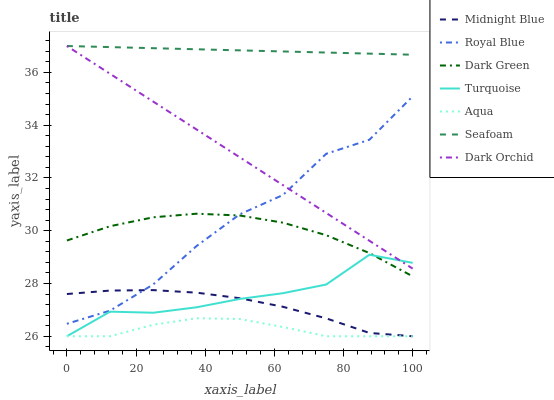Does Aqua have the minimum area under the curve?
Answer yes or no. Yes. Does Seafoam have the maximum area under the curve?
Answer yes or no. Yes. Does Midnight Blue have the minimum area under the curve?
Answer yes or no. No. Does Midnight Blue have the maximum area under the curve?
Answer yes or no. No. Is Seafoam the smoothest?
Answer yes or no. Yes. Is Royal Blue the roughest?
Answer yes or no. Yes. Is Midnight Blue the smoothest?
Answer yes or no. No. Is Midnight Blue the roughest?
Answer yes or no. No. Does Turquoise have the lowest value?
Answer yes or no. Yes. Does Seafoam have the lowest value?
Answer yes or no. No. Does Dark Orchid have the highest value?
Answer yes or no. Yes. Does Midnight Blue have the highest value?
Answer yes or no. No. Is Turquoise less than Seafoam?
Answer yes or no. Yes. Is Dark Green greater than Aqua?
Answer yes or no. Yes. Does Dark Orchid intersect Turquoise?
Answer yes or no. Yes. Is Dark Orchid less than Turquoise?
Answer yes or no. No. Is Dark Orchid greater than Turquoise?
Answer yes or no. No. Does Turquoise intersect Seafoam?
Answer yes or no. No. 